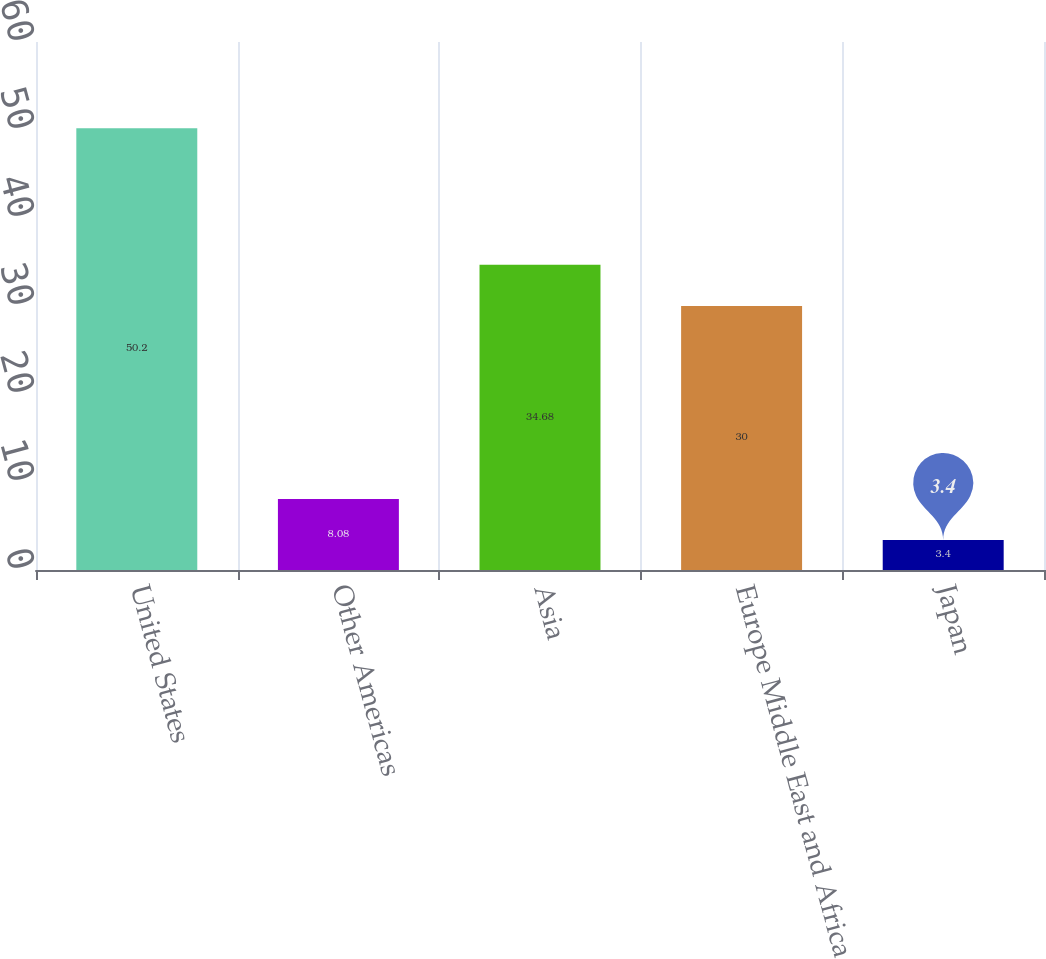Convert chart to OTSL. <chart><loc_0><loc_0><loc_500><loc_500><bar_chart><fcel>United States<fcel>Other Americas<fcel>Asia<fcel>Europe Middle East and Africa<fcel>Japan<nl><fcel>50.2<fcel>8.08<fcel>34.68<fcel>30<fcel>3.4<nl></chart> 